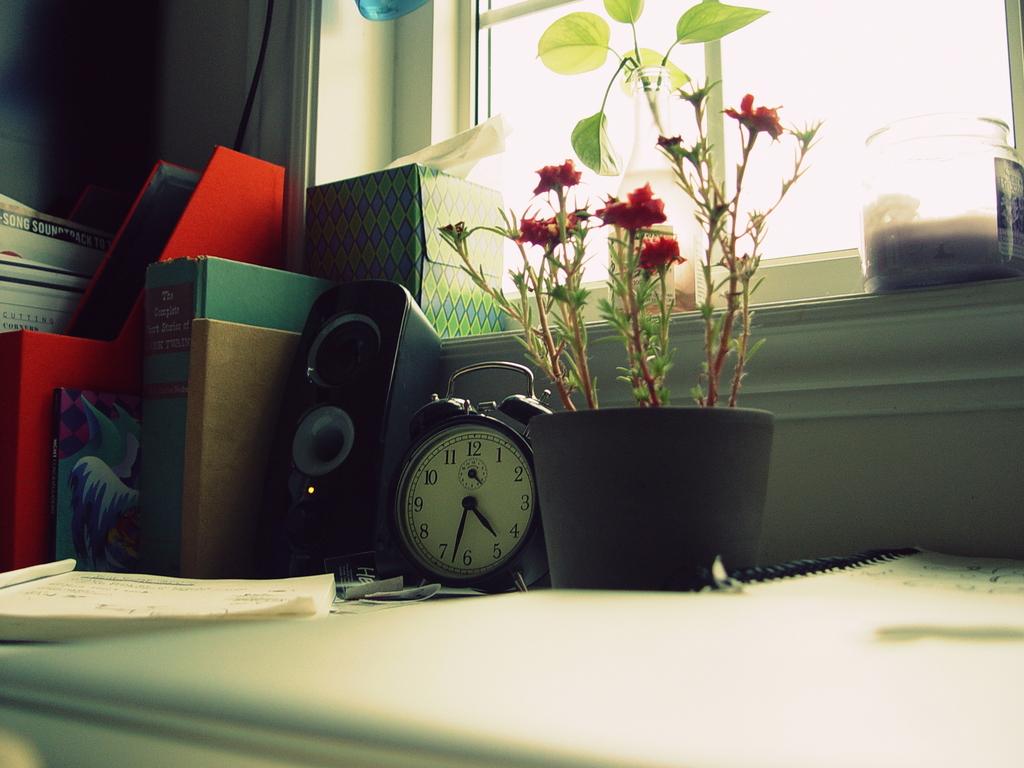What time is shown on the clock?
Provide a short and direct response. 4:33. What number is the big hand of the clock pointing to?
Your answer should be compact. 6. 